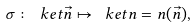<formula> <loc_0><loc_0><loc_500><loc_500>\sigma \colon \ k e t { \vec { n } } \mapsto \ k e t { n = n ( \vec { n } ) } ,</formula> 